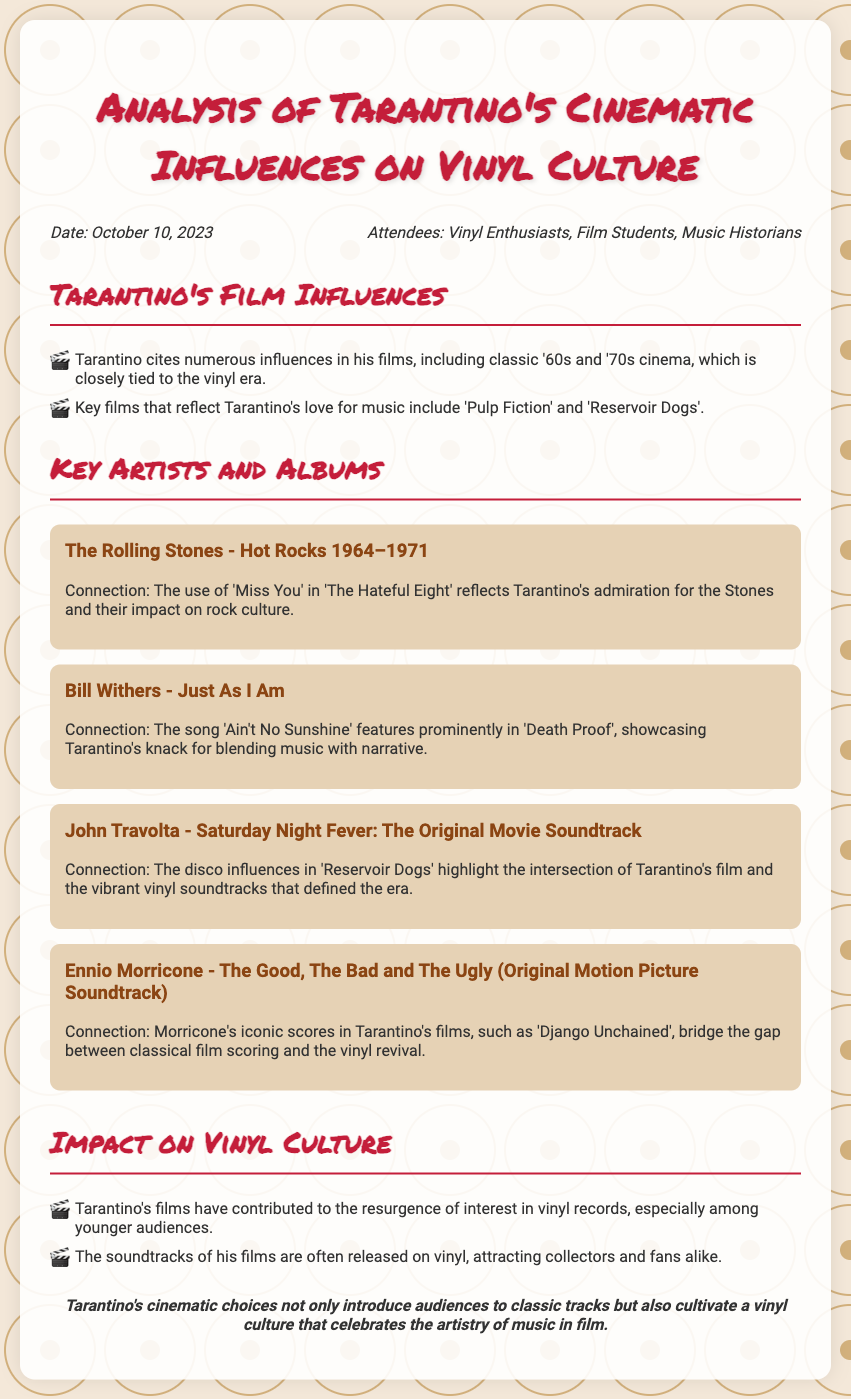What is the date of the meeting? The date is mentioned in the information section of the document.
Answer: October 10, 2023 Who are the attendees of the meeting? The attendees are listed in the information section of the document.
Answer: Vinyl Enthusiasts, Film Students, Music Historians Which artist is associated with the album "Hot Rocks 1964–1971"? The album title is linked to a specific artist in the document.
Answer: The Rolling Stones What song by Bill Withers is featured in 'Death Proof'? The document mentions the particular song associated with Bill Withers.
Answer: Ain't No Sunshine What is the significance of Tarantino's films on vinyl culture? The document explains the impact of Tarantino's films on vinyl interest.
Answer: Resurgence of interest in vinyl records What genre of music is highlighted in 'Reservoir Dogs'? The document notes the music genre related to the film.
Answer: Disco Name one soundtrack that features Ennio Morricone's work. The document lists soundtracks that include his music.
Answer: The Good, The Bad and The Ugly Which two Tarantino films are mentioned as reflecting his love for music? The document specifically cites these films as examples.
Answer: Pulp Fiction, Reservoir Dogs How does Tarantino's use of music support his storytelling? This question requires understanding the connection between music and film in Tarantino's work.
Answer: Blending music with narrative 